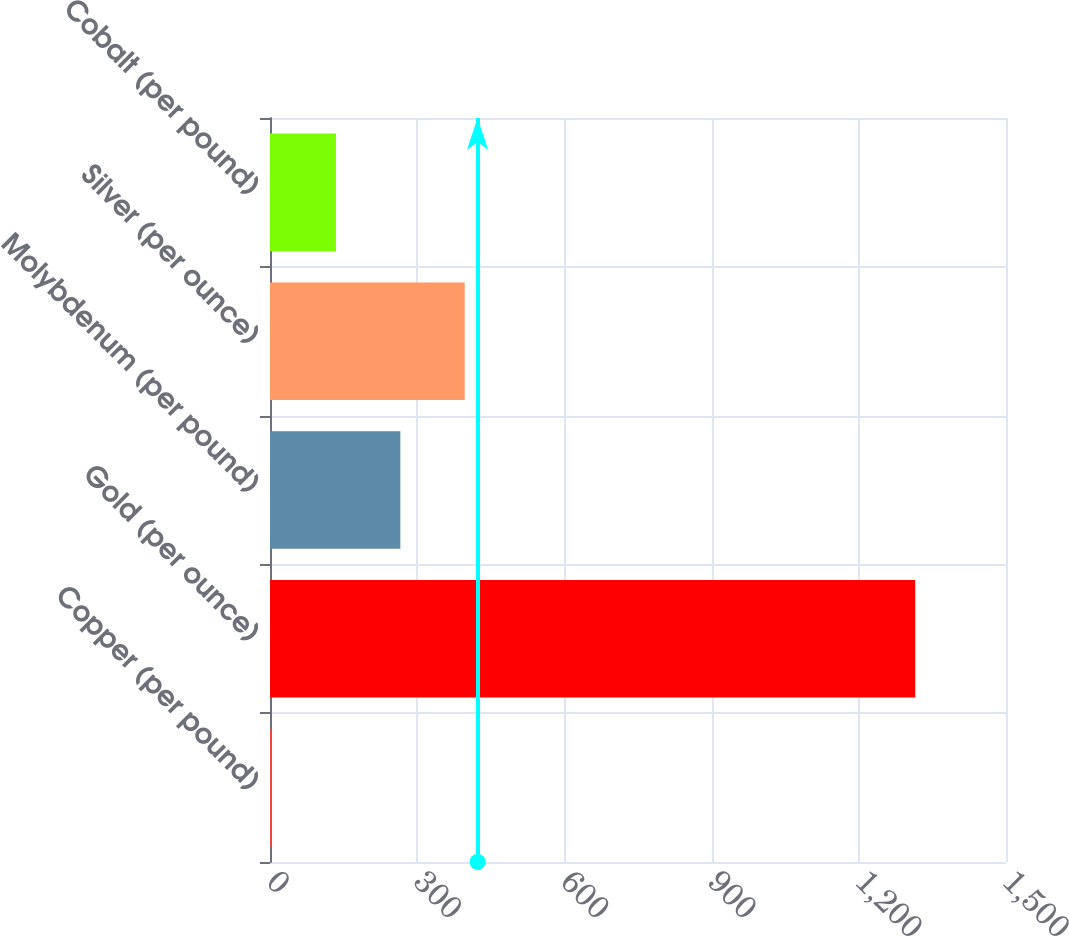Convert chart to OTSL. <chart><loc_0><loc_0><loc_500><loc_500><bar_chart><fcel>Copper (per pound)<fcel>Gold (per ounce)<fcel>Molybdenum (per pound)<fcel>Silver (per ounce)<fcel>Cobalt (per pound)<nl><fcel>3.3<fcel>1315<fcel>265.64<fcel>396.81<fcel>134.47<nl></chart> 